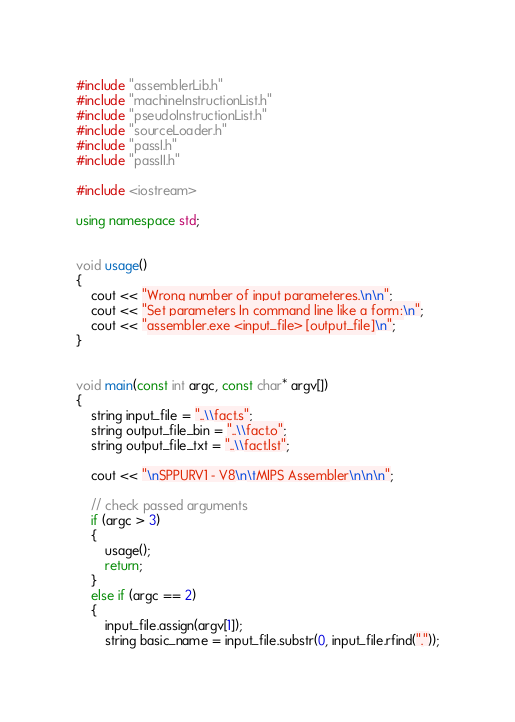<code> <loc_0><loc_0><loc_500><loc_500><_C++_>#include "assemblerLib.h"
#include "machineInstructionList.h"
#include "pseudoInstructionList.h"
#include "sourceLoader.h"
#include "passI.h"
#include "passII.h"

#include <iostream>

using namespace std;


void usage()
{
	cout << "Wrong number of input parameteres.\n\n";
	cout << "Set parameters In command line like a form:\n";
	cout << "assembler.exe <input_file> [output_file]\n";
}


void main(const int argc, const char* argv[])
{
	string input_file = "..\\fact.s";
	string output_file_bin = "..\\fact.o";
	string output_file_txt = "..\\fact.lst";

	cout << "\nSPPURV1 - V8\n\tMIPS Assembler\n\n\n";

	// check passed arguments
	if (argc > 3)
	{
		usage();
		return;
	}
	else if (argc == 2)
	{
		input_file.assign(argv[1]);
		string basic_name = input_file.substr(0, input_file.rfind("."));</code> 